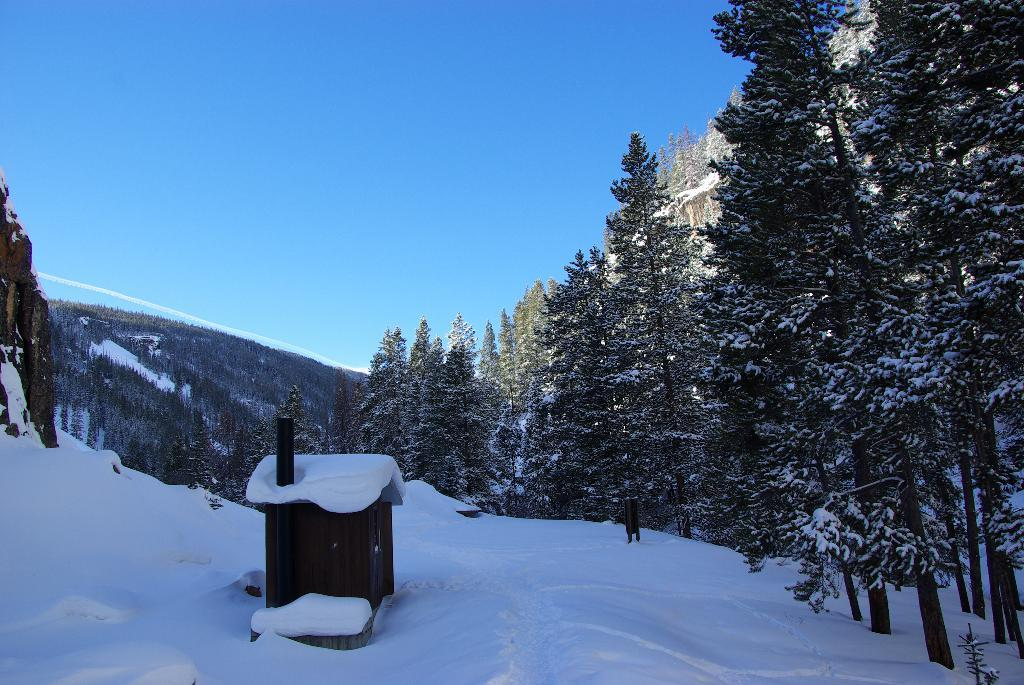What is the main feature of the landscape in the image? There is snow in the image. What type of natural elements can be seen in the image? There are trees in the image. What can be seen in the distance in the image? There is a mountain in the background of the image. What is the condition of the sky in the image? The sky is clear in the image. Can you see any marks left by the banana on the snow in the image? There is no banana present in the image, so there are no marks left by it. What type of afterthought is depicted in the image? There is no afterthought depicted in the image; it features a snowy landscape with trees, a mountain, and a clear sky. 